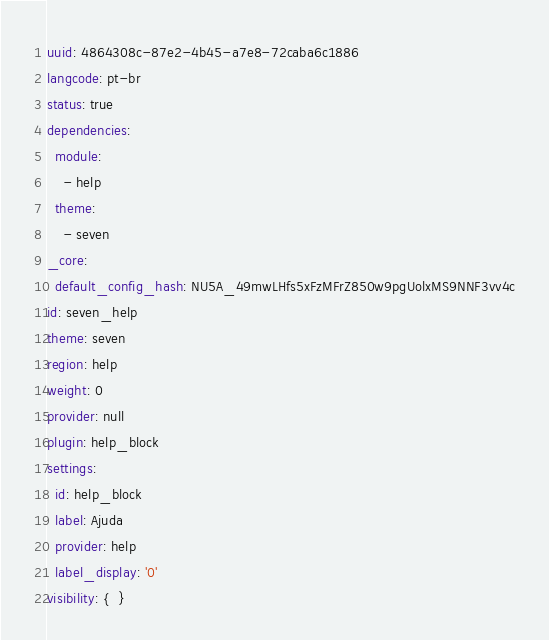<code> <loc_0><loc_0><loc_500><loc_500><_YAML_>uuid: 4864308c-87e2-4b45-a7e8-72caba6c1886
langcode: pt-br
status: true
dependencies:
  module:
    - help
  theme:
    - seven
_core:
  default_config_hash: NU5A_49mwLHfs5xFzMFrZ850w9pgUolxMS9NNF3vv4c
id: seven_help
theme: seven
region: help
weight: 0
provider: null
plugin: help_block
settings:
  id: help_block
  label: Ajuda
  provider: help
  label_display: '0'
visibility: {  }
</code> 